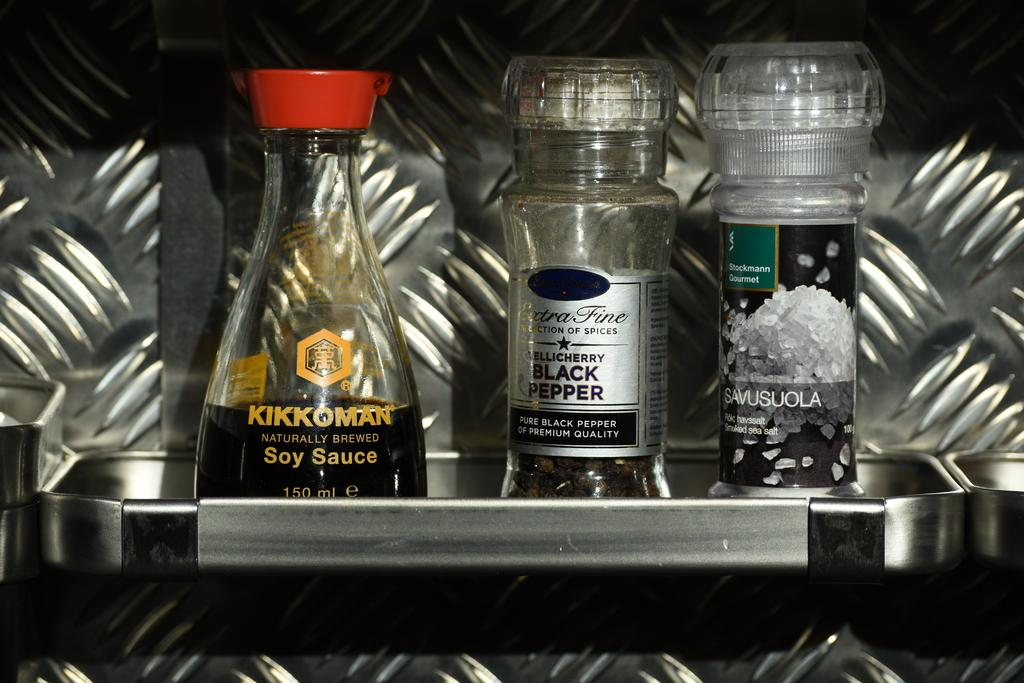<image>
Describe the image concisely. Salt and pepper sitting next to kikiman soy sauce 